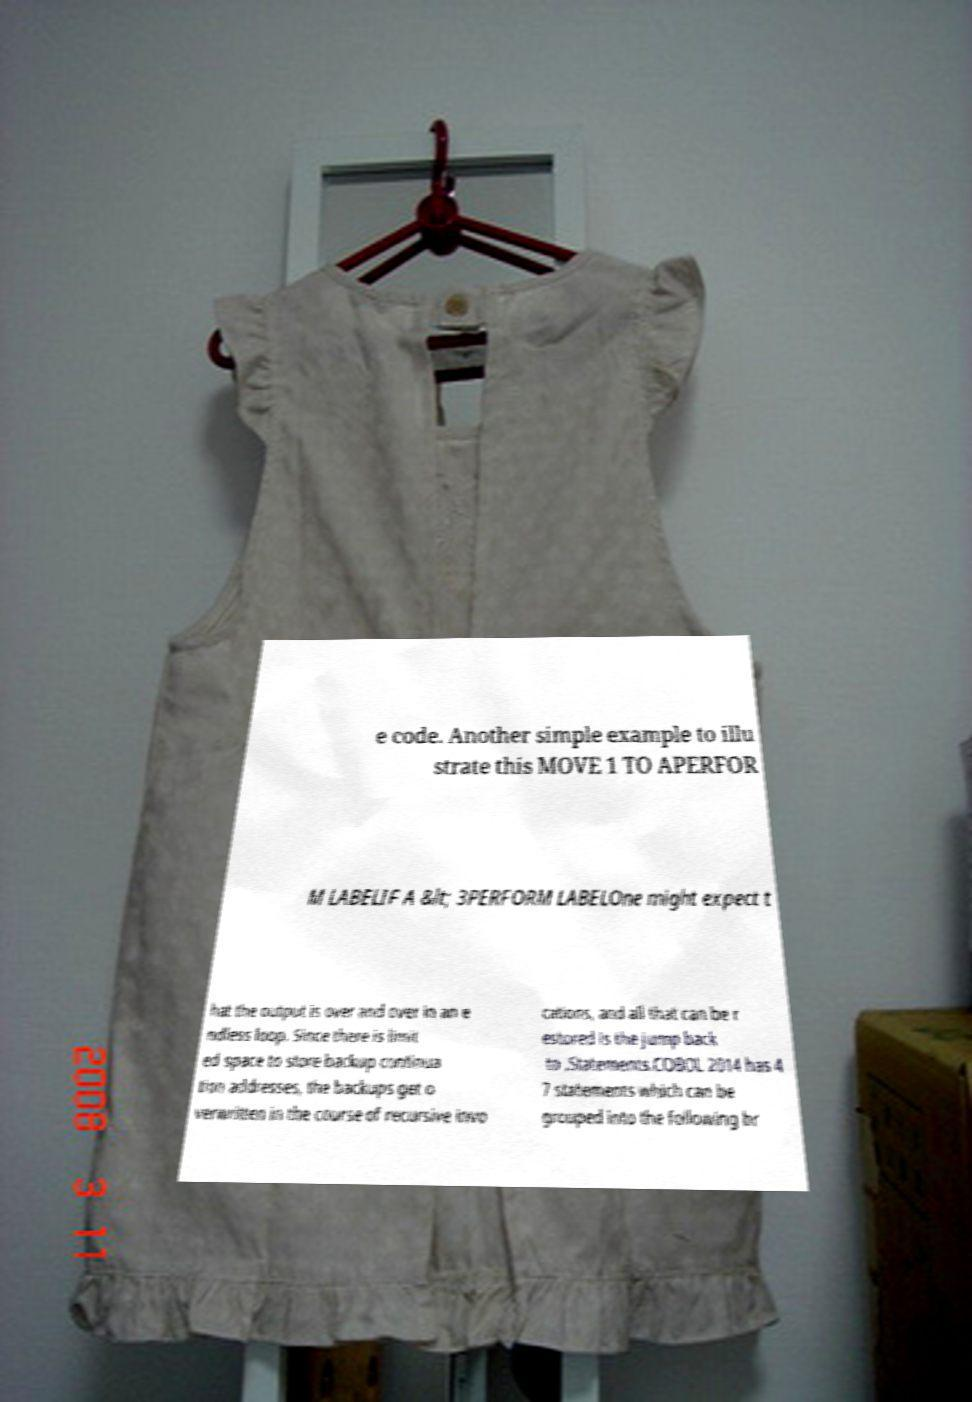There's text embedded in this image that I need extracted. Can you transcribe it verbatim? e code. Another simple example to illu strate this MOVE 1 TO APERFOR M LABELIF A &lt; 3PERFORM LABELOne might expect t hat the output is over and over in an e ndless loop. Since there is limit ed space to store backup continua tion addresses, the backups get o verwritten in the course of recursive invo cations, and all that can be r estored is the jump back to .Statements.COBOL 2014 has 4 7 statements which can be grouped into the following br 